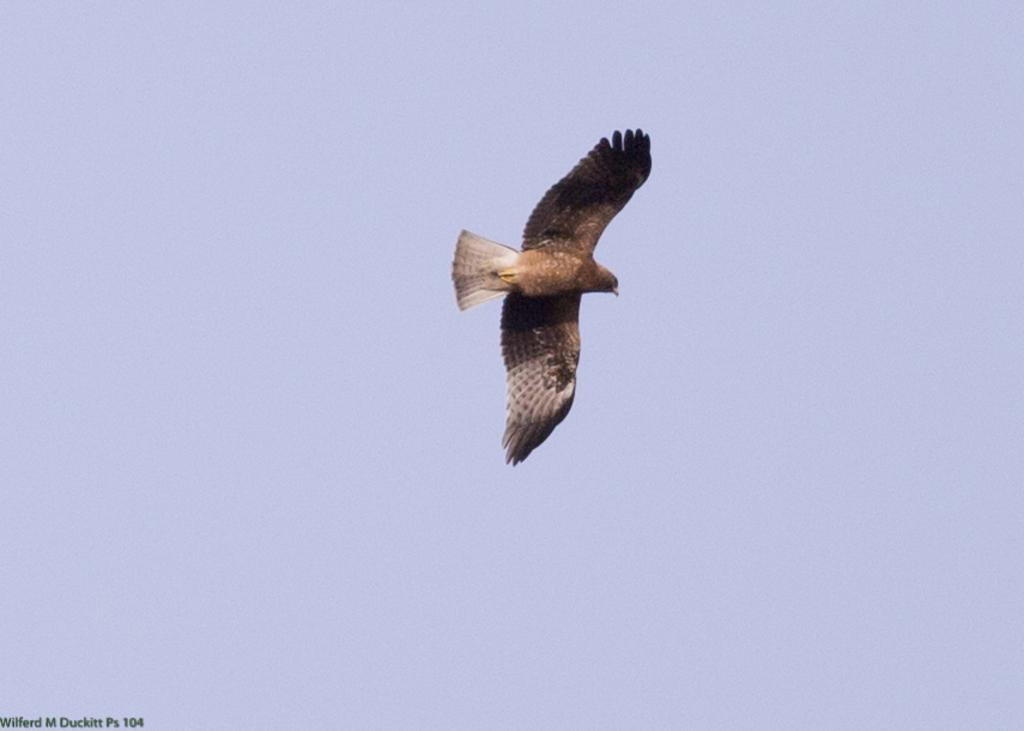What is the main subject of the image? The main subject of the image is a bird flying in the air. Can you describe any additional features or elements in the image? There is a watermark in the left bottom corner of the image, and the background is a blue sky. What type of eggnog is being served to the horses in the image? There are no horses or eggnog present in the image; it features a bird flying in the air against a blue sky background. 